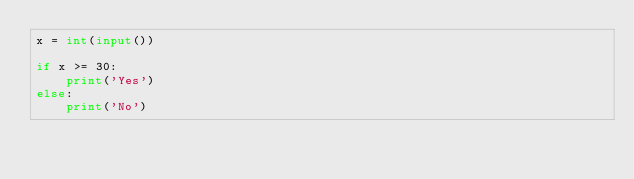Convert code to text. <code><loc_0><loc_0><loc_500><loc_500><_Python_>x = int(input())

if x >= 30:
    print('Yes')
else:
    print('No')</code> 